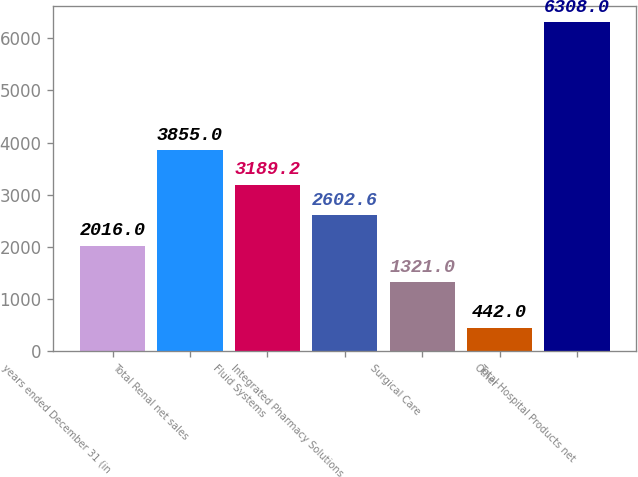Convert chart. <chart><loc_0><loc_0><loc_500><loc_500><bar_chart><fcel>years ended December 31 (in<fcel>Total Renal net sales<fcel>Fluid Systems<fcel>Integrated Pharmacy Solutions<fcel>Surgical Care<fcel>Other<fcel>Total Hospital Products net<nl><fcel>2016<fcel>3855<fcel>3189.2<fcel>2602.6<fcel>1321<fcel>442<fcel>6308<nl></chart> 